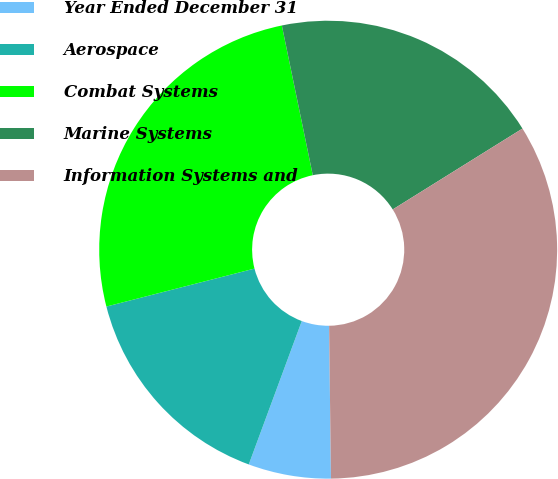Convert chart to OTSL. <chart><loc_0><loc_0><loc_500><loc_500><pie_chart><fcel>Year Ended December 31<fcel>Aerospace<fcel>Combat Systems<fcel>Marine Systems<fcel>Information Systems and<nl><fcel>5.83%<fcel>15.37%<fcel>25.75%<fcel>19.37%<fcel>33.68%<nl></chart> 